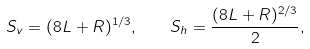Convert formula to latex. <formula><loc_0><loc_0><loc_500><loc_500>S _ { v } = ( 8 L + R ) ^ { 1 / 3 } , \quad S _ { h } = \frac { ( 8 L + R ) ^ { 2 / 3 } } { 2 } ,</formula> 